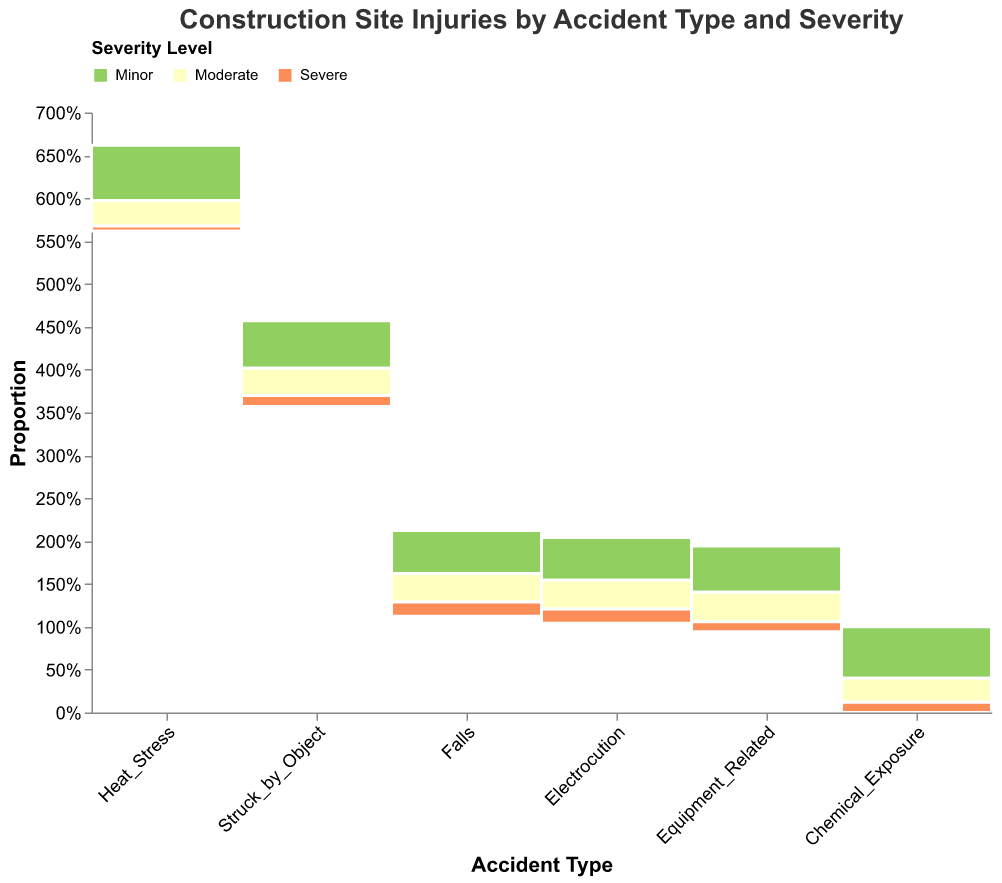Which type of accident has the highest number of minor injuries? The height of the `Minor` segment is the tallest for `Falls`, indicating the highest number of minor injuries.
Answer: Falls Which severity level has the lowest count for Heat Stress? The height of the `Severe` segment for `Heat_Stress` is the shortest, indicating the lowest count.
Answer: Severe How does the number of moderate injuries from Struck by Object compare to those from Equipment Related accidents? The height of the `Moderate` segment for `Struck_by_Object` is taller than for `Equipment_Related`, indicating more moderate injuries from `Struck_by_Object`.
Answer: Higher What proportion of falls result in severe injuries? Divide the total count of severe injuries from falls (15) by the total count of falls injuries (45 minor + 30 moderate + 15 severe = 90). So, 15/90 = 0.1667 or 16.67%.
Answer: 16.67% What is the accident type with the second highest number of severe injuries? The largest `Severe` segment, after `Falls`, belongs to `Struck_by_Object`.
Answer: Struck by Object Are there more minor injuries from Equipment Related accidents or Electrocution? The height of the `Minor` segment for `Equipment_Related` is taller than for `Electrocution`, indicating more minor injuries from `Equipment_Related`.
Answer: Equipment Related Which accident type has the most balanced distribution of injuries across different severity levels? `Falls` has noticeable differences in segment heights, while `Chemical_Exposure` segments appear closer in height, indicating a more balanced distribution.
Answer: Chemical Exposure What is the severity level with the highest overall injury count across all accident types? Summing up the different severity levels across all accident types, `Minor` injuries have the highest overall count.
Answer: Minor Which type of accident has the highest number of moderate injuries? The tallest `Moderate` segment is for `Falls`, indicating the highest number of moderate injuries.
Answer: Falls Are there any accident types where severe injuries are more common than minor injuries? No, for all accident types, the `Minor` segments are taller than the `Severe` segments, indicating minor injuries are always more common.
Answer: No 